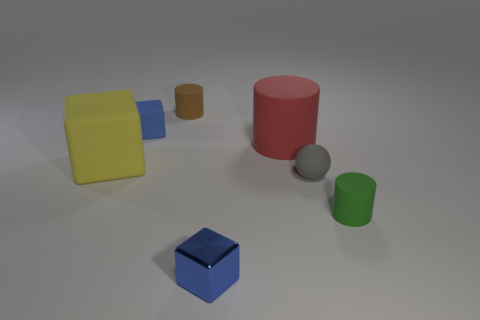Does the blue cube in front of the small rubber sphere have the same size as the rubber cube that is in front of the blue matte block?
Make the answer very short. No. Are there any red things that have the same shape as the yellow thing?
Provide a succinct answer. No. Are there an equal number of yellow rubber things that are in front of the tiny blue rubber block and purple metallic cylinders?
Provide a short and direct response. No. There is a blue rubber thing; is its size the same as the cylinder in front of the red matte cylinder?
Provide a succinct answer. Yes. How many big yellow things are made of the same material as the gray sphere?
Provide a succinct answer. 1. Does the green matte thing have the same size as the rubber sphere?
Provide a short and direct response. Yes. Is there any other thing that has the same color as the large matte block?
Provide a succinct answer. No. There is a tiny matte thing that is both right of the blue matte cube and behind the big yellow rubber cube; what shape is it?
Keep it short and to the point. Cylinder. There is a blue block that is in front of the yellow object; what size is it?
Make the answer very short. Small. There is a large thing that is to the left of the blue cube in front of the large yellow object; how many green matte cylinders are on the left side of it?
Your answer should be very brief. 0. 